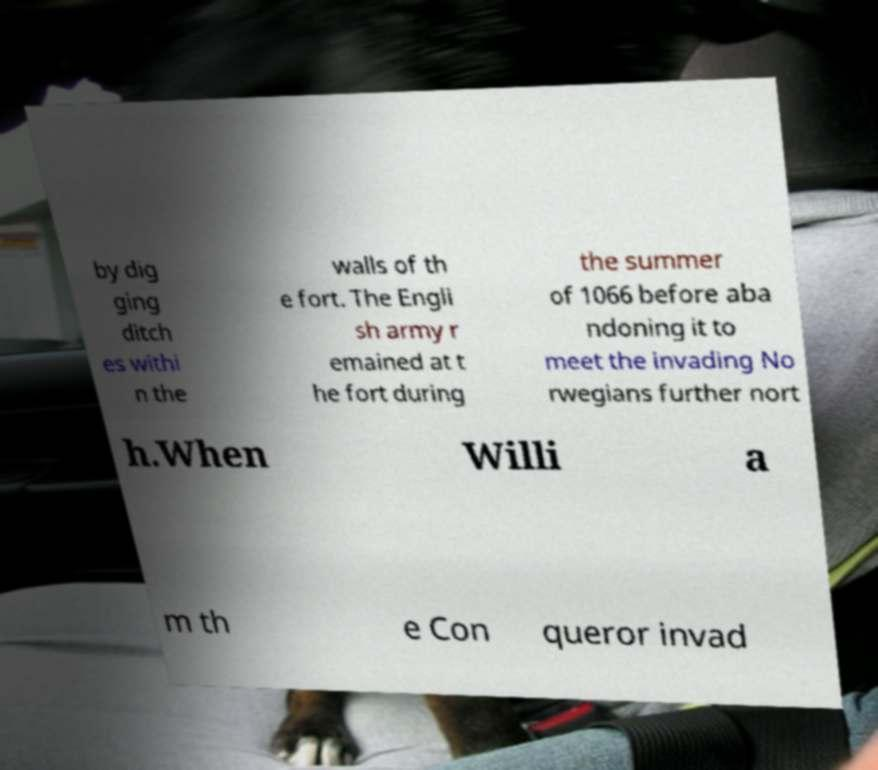What messages or text are displayed in this image? I need them in a readable, typed format. by dig ging ditch es withi n the walls of th e fort. The Engli sh army r emained at t he fort during the summer of 1066 before aba ndoning it to meet the invading No rwegians further nort h.When Willi a m th e Con queror invad 